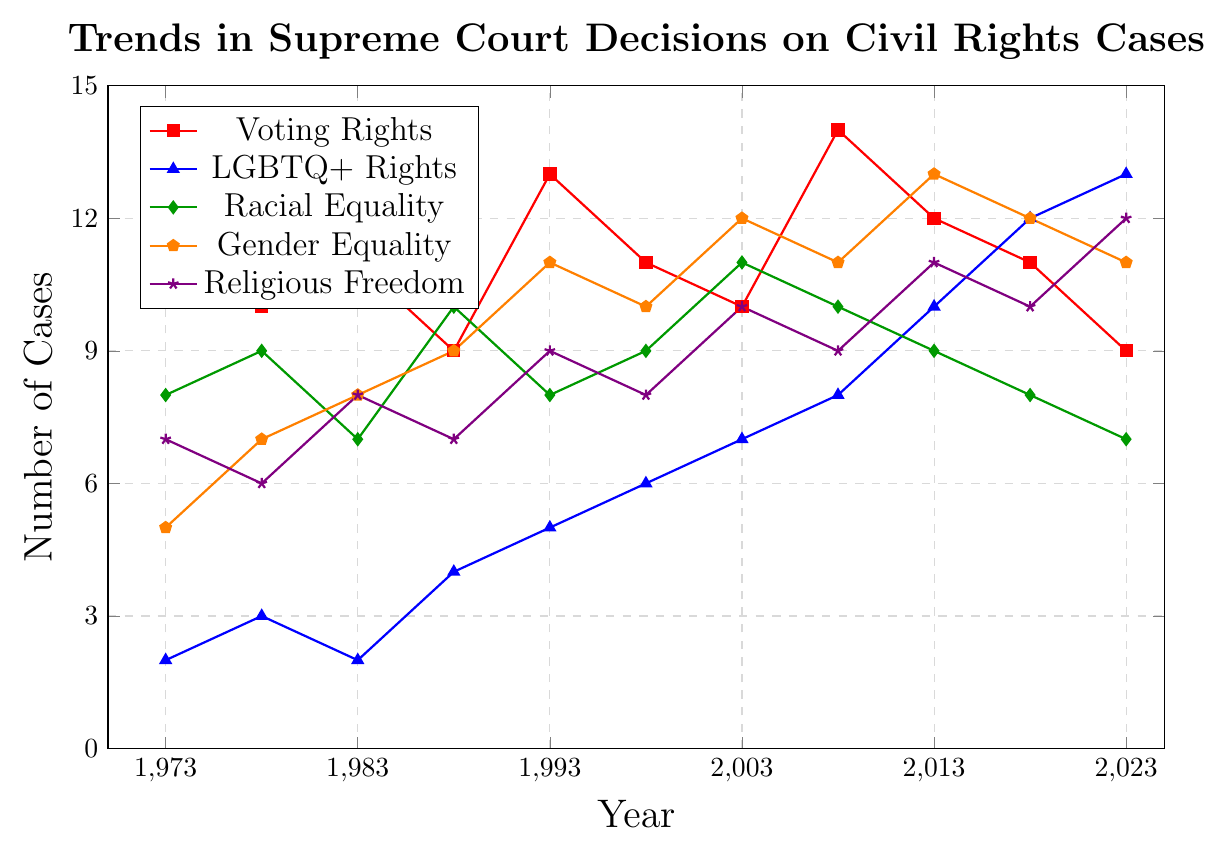What type of civil rights cases had the most decisions in 2023? Look at the 2023 data points and compare the values for each category. The highest value corresponds to Religious Freedom with a value of 12.
Answer: Religious Freedom Which category experienced the most growth in the number of cases from 1973 to 2023? Calculate the difference between the 2023 and 1973 values for each category: Voting Rights (9-12 = -3), LGBTQ+ Rights (13-2 = 11), Racial Equality (7-8 = -1), Gender Equality (11-5 = 6), and Religious Freedom (12-7 = 5). LGBTQ+ Rights had the highest growth of 11.
Answer: LGBTQ+ Rights How did the number of Voting Rights cases change from 2008 to 2018? Look at the values for Voting Rights in 2008 and 2018 and subtract the latter from the former (14 - 11).
Answer: Decreased by 3 During which decade did Gender Equality cases see the highest increase? Calculate the difference for each decade: 1973-1983 (8-5=3), 1983-1993 (11-8=3), 1993-2003 (12-11=1), 2003-2013 (13-12=1), 2013-2023 (11-13=-2). The highest increase is from 1973-1983 and 1983-1993.
Answer: 1970s and 1980s What was the trend in Racial Equality cases from 2003 to 2023? Look at the values from 2003 (11) to 2023 (7) and observe the general direction. The number decreases, indicating a downward trend.
Answer: Decreasing Which category had the least number of cases in 2013? Compare the number of cases for each category in 2013 and find the lowest value, which is Racial Equality with 9 cases.
Answer: Racial Equality Compare the number of Voting Rights and Gender Equality cases in 1993. Which had more and by how many? Look at the values in 1993 for Voting Rights (13) and Gender Equality (11). Subtract the smaller number from the larger (13 - 11 = 2). Voting Rights had 2 more cases.
Answer: Voting Rights by 2 What is the average number of LGBTQ+ Rights cases over the plotted years? Add the values for LGBTQ+ Rights and divide by the number of data points: (2+3+2+4+5+6+7+8+10+12+13) / 11 = 72 / 11.
Answer: 6.55 What visual pattern can be observed in the trend for Religious Freedom cases? Look at the pattern of the line for Religious Freedom (violet). The line is generally increasing with slight fluctuations, indicating an overall upward trend.
Answer: Upward Trend Which year had the highest number of total civil rights cases combined? Sum the values for all categories for each year. The year with the highest sum is 2013: Voting Rights (12) + LGBTQ+ Rights (10) + Racial Equality (9) + Gender Equality (13) + Religious Freedom (11) = 55.
Answer: 2013 